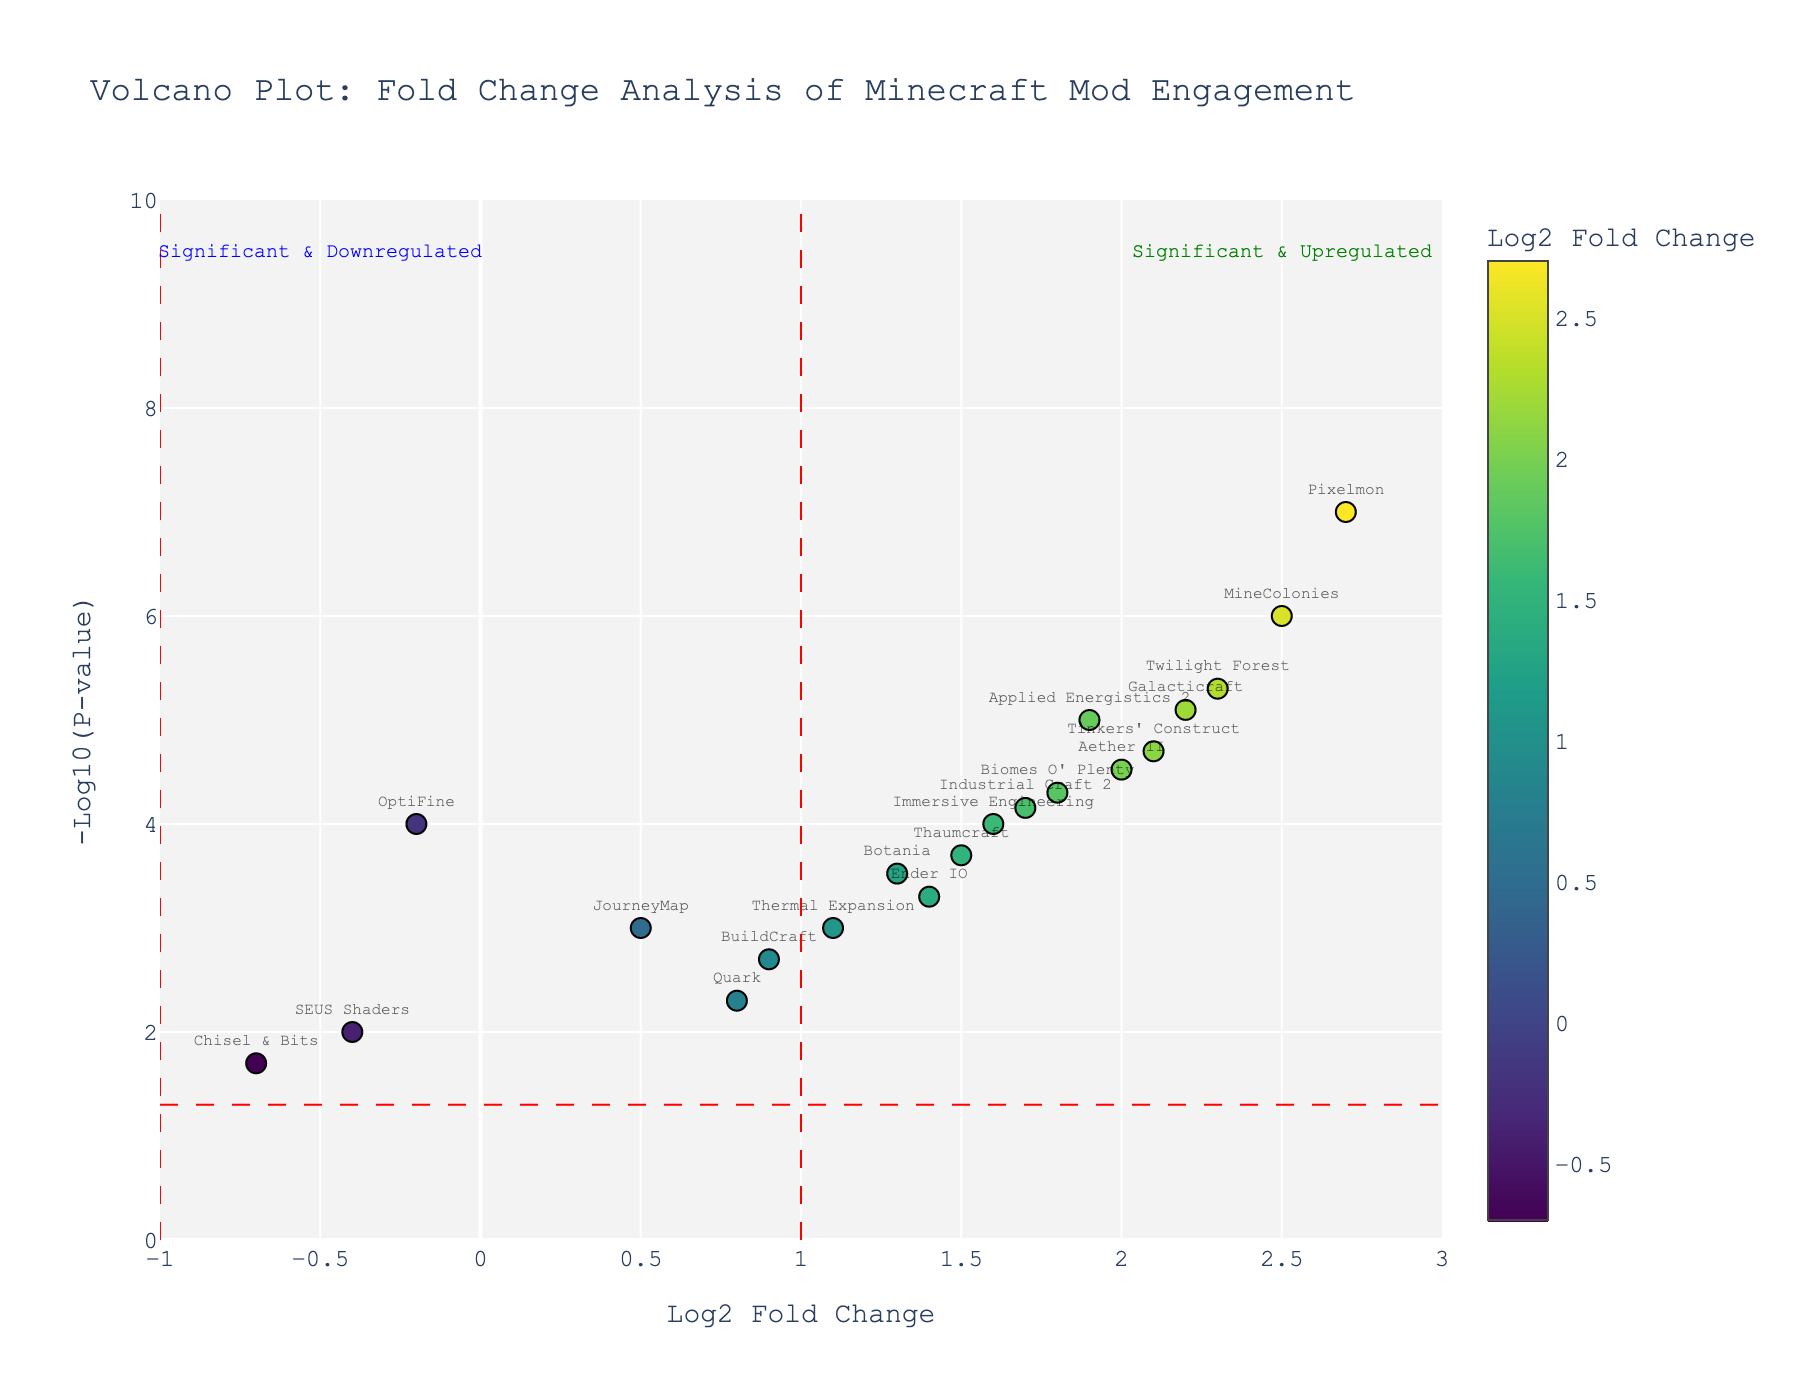Which mod has the highest log2 fold change? The mod with the highest log2 fold change is represented by the rightmost data point on the x-axis of the plot.
Answer: Pixelmon What is the log2 fold change and p-value for the mod "Thaumcraft"? Locate the point labeled "Thaumcraft" on the plot. Look at its x and y coordinates for log2 fold change and -log10(p-value) respectively. Convert the -log10(p-value) back to p-value.
Answer: Log2 fold change: 1.5, p-value: 0.0002 What is the significance threshold for p-values in this plot? Identify the horizontal line crossing the y-axis and note its y-value, which represents the -log10(0.05). Calculate the p-value from this.
Answer: 0.05 How many mods are significantly downregulated (log2 fold change < -1 and p-value < 0.05)? Locate the vertical line at log2 fold change = -1 and the horizontal line at -log10(0.05). Count the data points in the area to the left of the vertical line and above the horizontal line.
Answer: 0 Which mods have a log2 fold change greater than 2 and are highly significant (p-value < 0.0001)? Identify the data points to the right of log2 fold change = 2 and above the horizontal line corresponding to -log10(0.0001).
Answer: Twilight Forest, Galacticraft, MineColonies, Pixelmon What is the range of log2 fold change values represented in the plot? Observe the x-axis range from the plot, noting the minimum and maximum limits.
Answer: -0.7 to 2.7 Are there more significantly upregulated or downregulated mods? Compare the number of data points above the horizontal line at -log10(0.05) to the right of log2 fold change = 1 and to the left of log2 fold change = -1.
Answer: More upregulated mods 